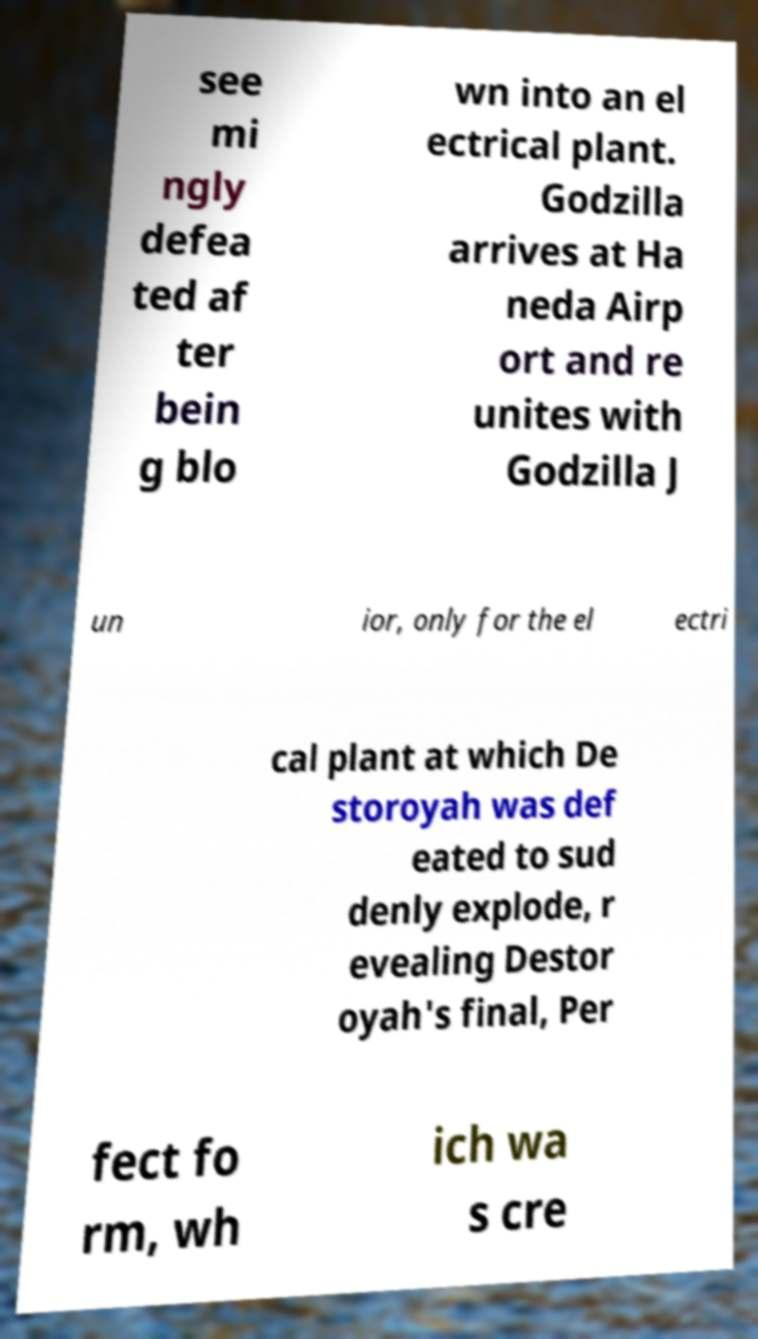There's text embedded in this image that I need extracted. Can you transcribe it verbatim? see mi ngly defea ted af ter bein g blo wn into an el ectrical plant. Godzilla arrives at Ha neda Airp ort and re unites with Godzilla J un ior, only for the el ectri cal plant at which De storoyah was def eated to sud denly explode, r evealing Destor oyah's final, Per fect fo rm, wh ich wa s cre 